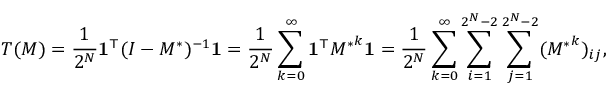<formula> <loc_0><loc_0><loc_500><loc_500>T ( M ) = \frac { 1 } { 2 ^ { N } } 1 ^ { \top } ( I - M ^ { \ast } ) ^ { - 1 } 1 = \frac { 1 } { 2 ^ { N } } \sum _ { k = 0 } ^ { \infty } 1 ^ { \top } { M ^ { \ast } } ^ { k } 1 = \frac { 1 } { 2 ^ { N } } \sum _ { k = 0 } ^ { \infty } \sum _ { i = 1 } ^ { 2 ^ { N } - 2 } \sum _ { j = 1 } ^ { 2 ^ { N } - 2 } ( { M ^ { \ast } } ^ { k } ) _ { i j } ,</formula> 